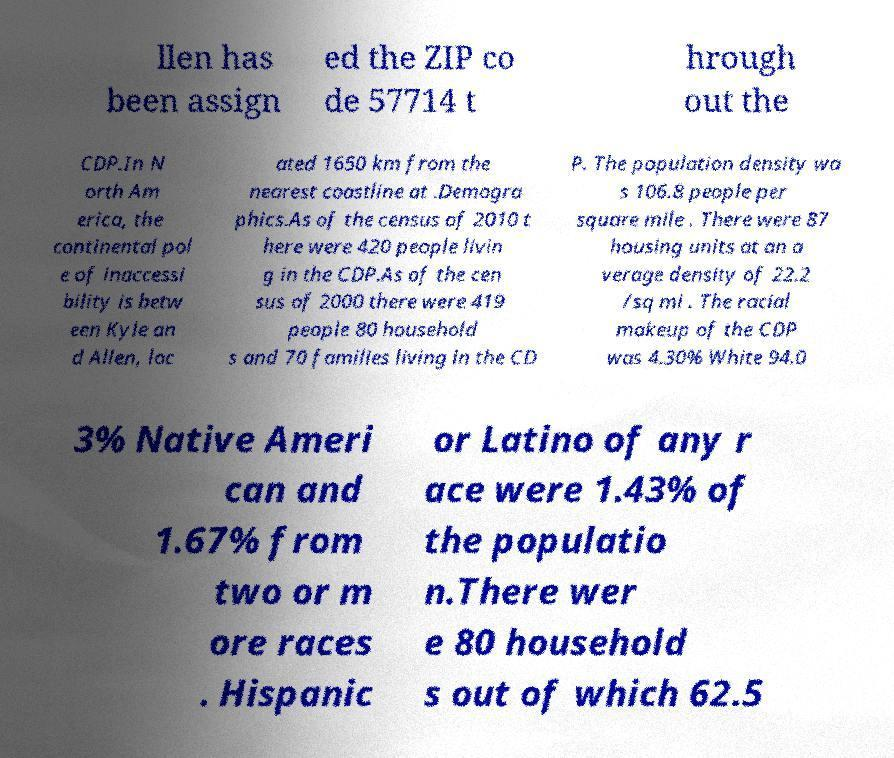Please read and relay the text visible in this image. What does it say? llen has been assign ed the ZIP co de 57714 t hrough out the CDP.In N orth Am erica, the continental pol e of inaccessi bility is betw een Kyle an d Allen, loc ated 1650 km from the nearest coastline at .Demogra phics.As of the census of 2010 t here were 420 people livin g in the CDP.As of the cen sus of 2000 there were 419 people 80 household s and 70 families living in the CD P. The population density wa s 106.8 people per square mile . There were 87 housing units at an a verage density of 22.2 /sq mi . The racial makeup of the CDP was 4.30% White 94.0 3% Native Ameri can and 1.67% from two or m ore races . Hispanic or Latino of any r ace were 1.43% of the populatio n.There wer e 80 household s out of which 62.5 